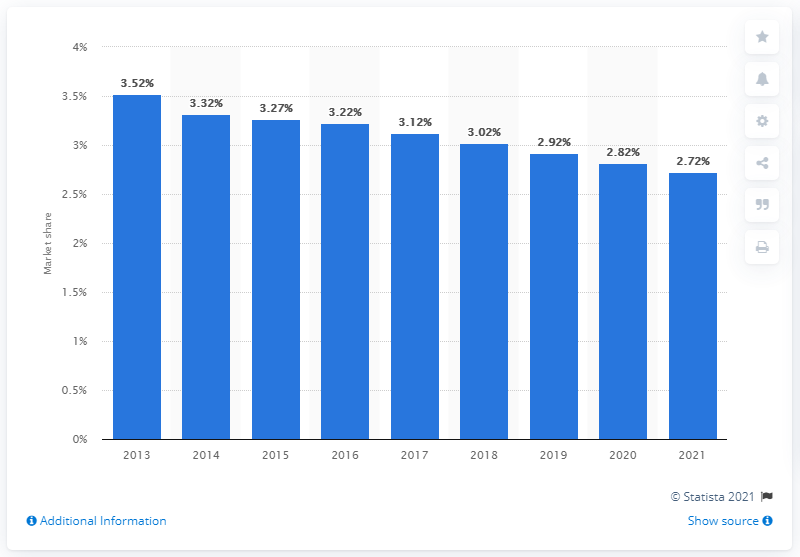Specify some key components in this picture. Johnson & Johnson held a market share of 3.27% of the global over-the-counter and nutritionals market in 2015. 